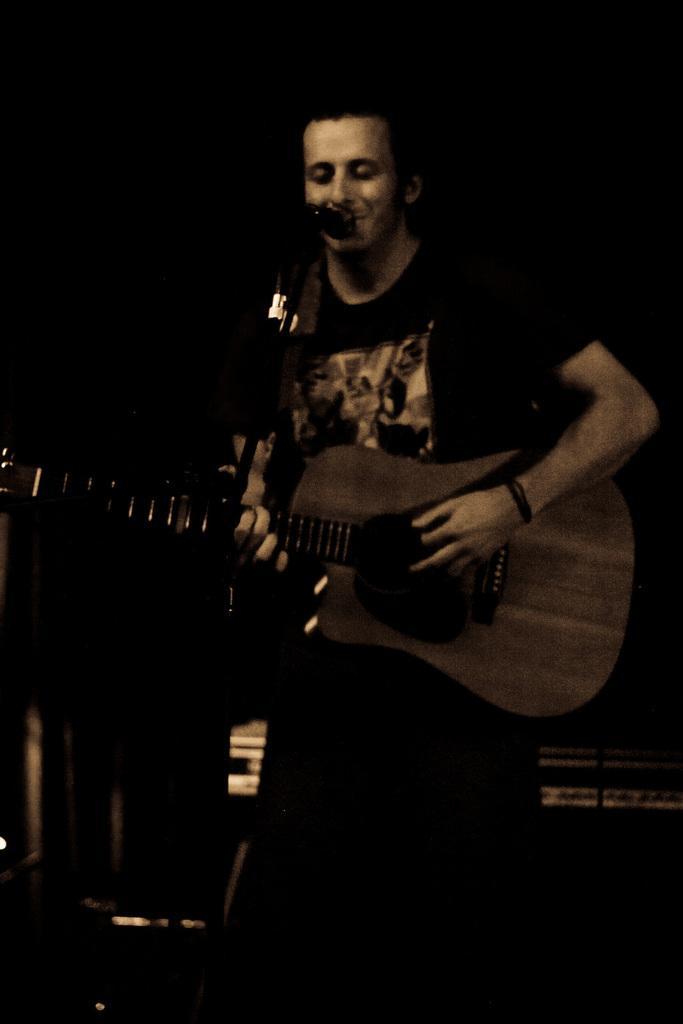How would you summarize this image in a sentence or two? In this picture man singing and playing a guitar. 